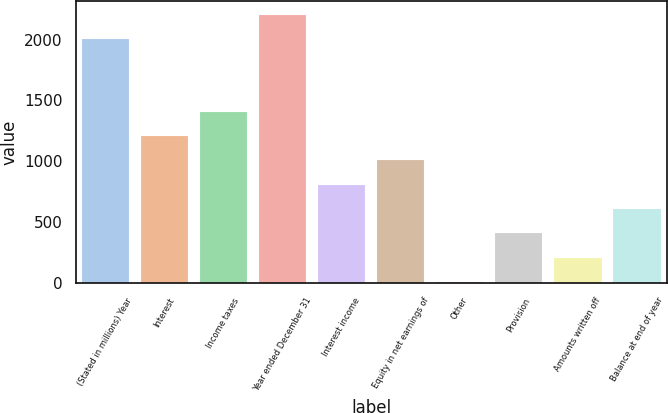<chart> <loc_0><loc_0><loc_500><loc_500><bar_chart><fcel>(Stated in millions) Year<fcel>Interest<fcel>Income taxes<fcel>Year ended December 31<fcel>Interest income<fcel>Equity in net earnings of<fcel>Other<fcel>Provision<fcel>Amounts written off<fcel>Balance at end of year<nl><fcel>2006<fcel>1207.2<fcel>1406.9<fcel>2205.7<fcel>807.8<fcel>1007.5<fcel>9<fcel>408.4<fcel>208.7<fcel>608.1<nl></chart> 